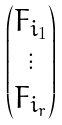<formula> <loc_0><loc_0><loc_500><loc_500>\begin{pmatrix} F _ { i _ { 1 } } \\ \vdots \\ F _ { i _ { r } } \end{pmatrix}</formula> 